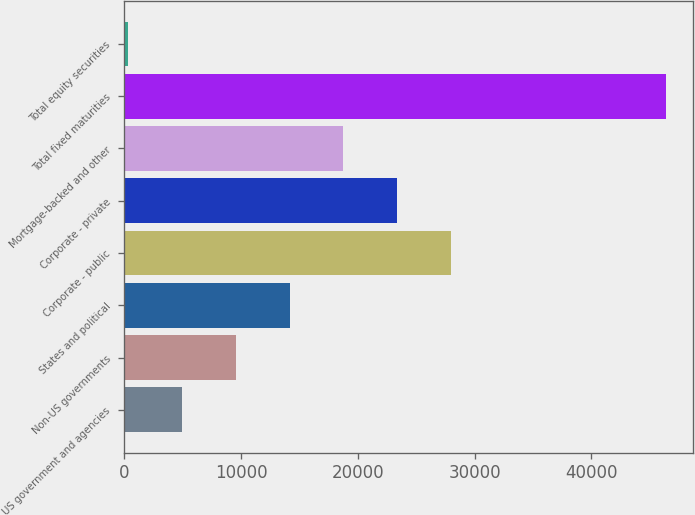Convert chart to OTSL. <chart><loc_0><loc_0><loc_500><loc_500><bar_chart><fcel>US government and agencies<fcel>Non-US governments<fcel>States and political<fcel>Corporate - public<fcel>Corporate - private<fcel>Mortgage-backed and other<fcel>Total fixed maturities<fcel>Total equity securities<nl><fcel>4929.14<fcel>9537.98<fcel>14146.8<fcel>27973.3<fcel>23364.5<fcel>18755.7<fcel>46408.7<fcel>320.3<nl></chart> 